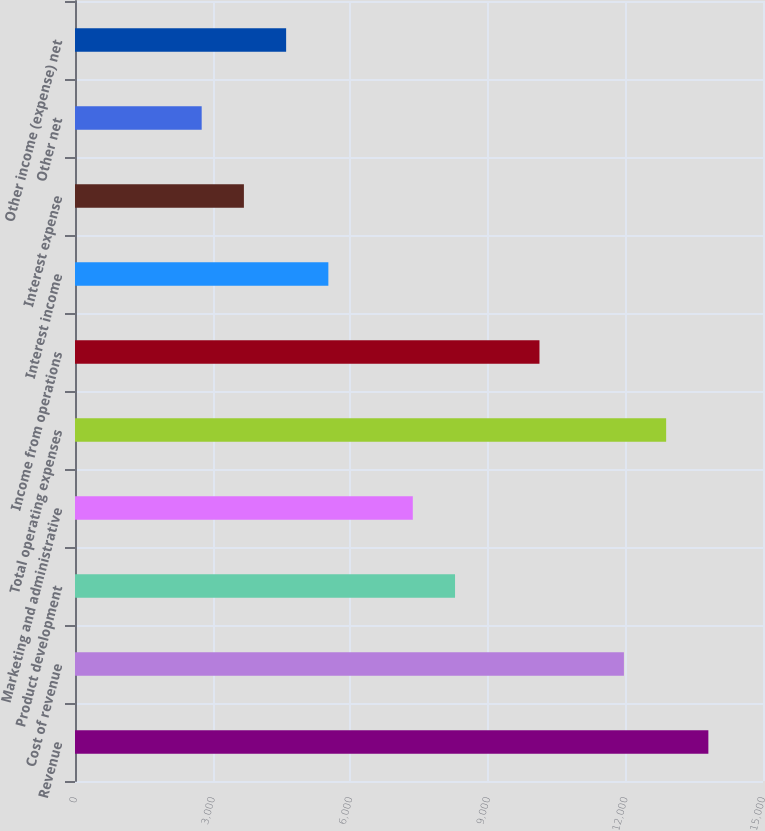Convert chart. <chart><loc_0><loc_0><loc_500><loc_500><bar_chart><fcel>Revenue<fcel>Cost of revenue<fcel>Product development<fcel>Marketing and administrative<fcel>Total operating expenses<fcel>Income from operations<fcel>Interest income<fcel>Interest expense<fcel>Other net<fcel>Other income (expense) net<nl><fcel>13808.9<fcel>11967.7<fcel>8285.45<fcel>7364.88<fcel>12888.3<fcel>10126.6<fcel>5523.74<fcel>3682.6<fcel>2762.03<fcel>4603.17<nl></chart> 